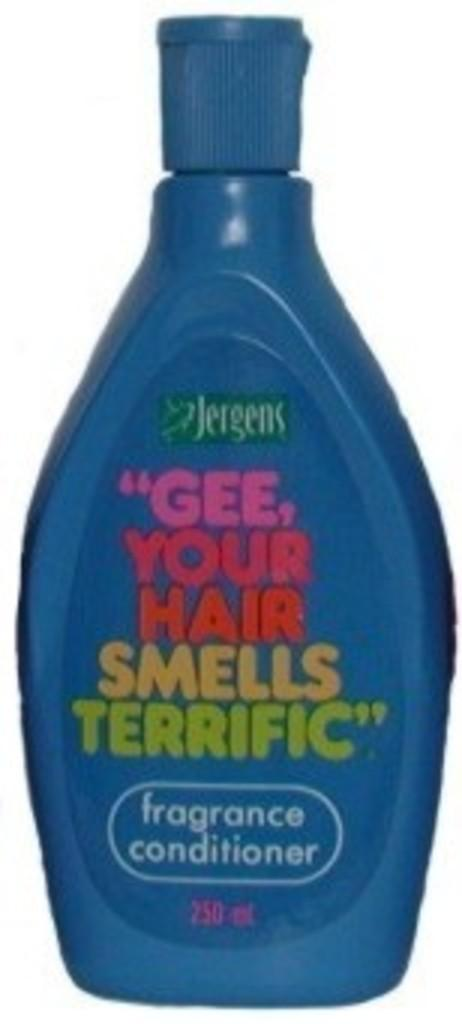<image>
Offer a succinct explanation of the picture presented. A 250ml bottle of fragrance conditioner by Jergens. 